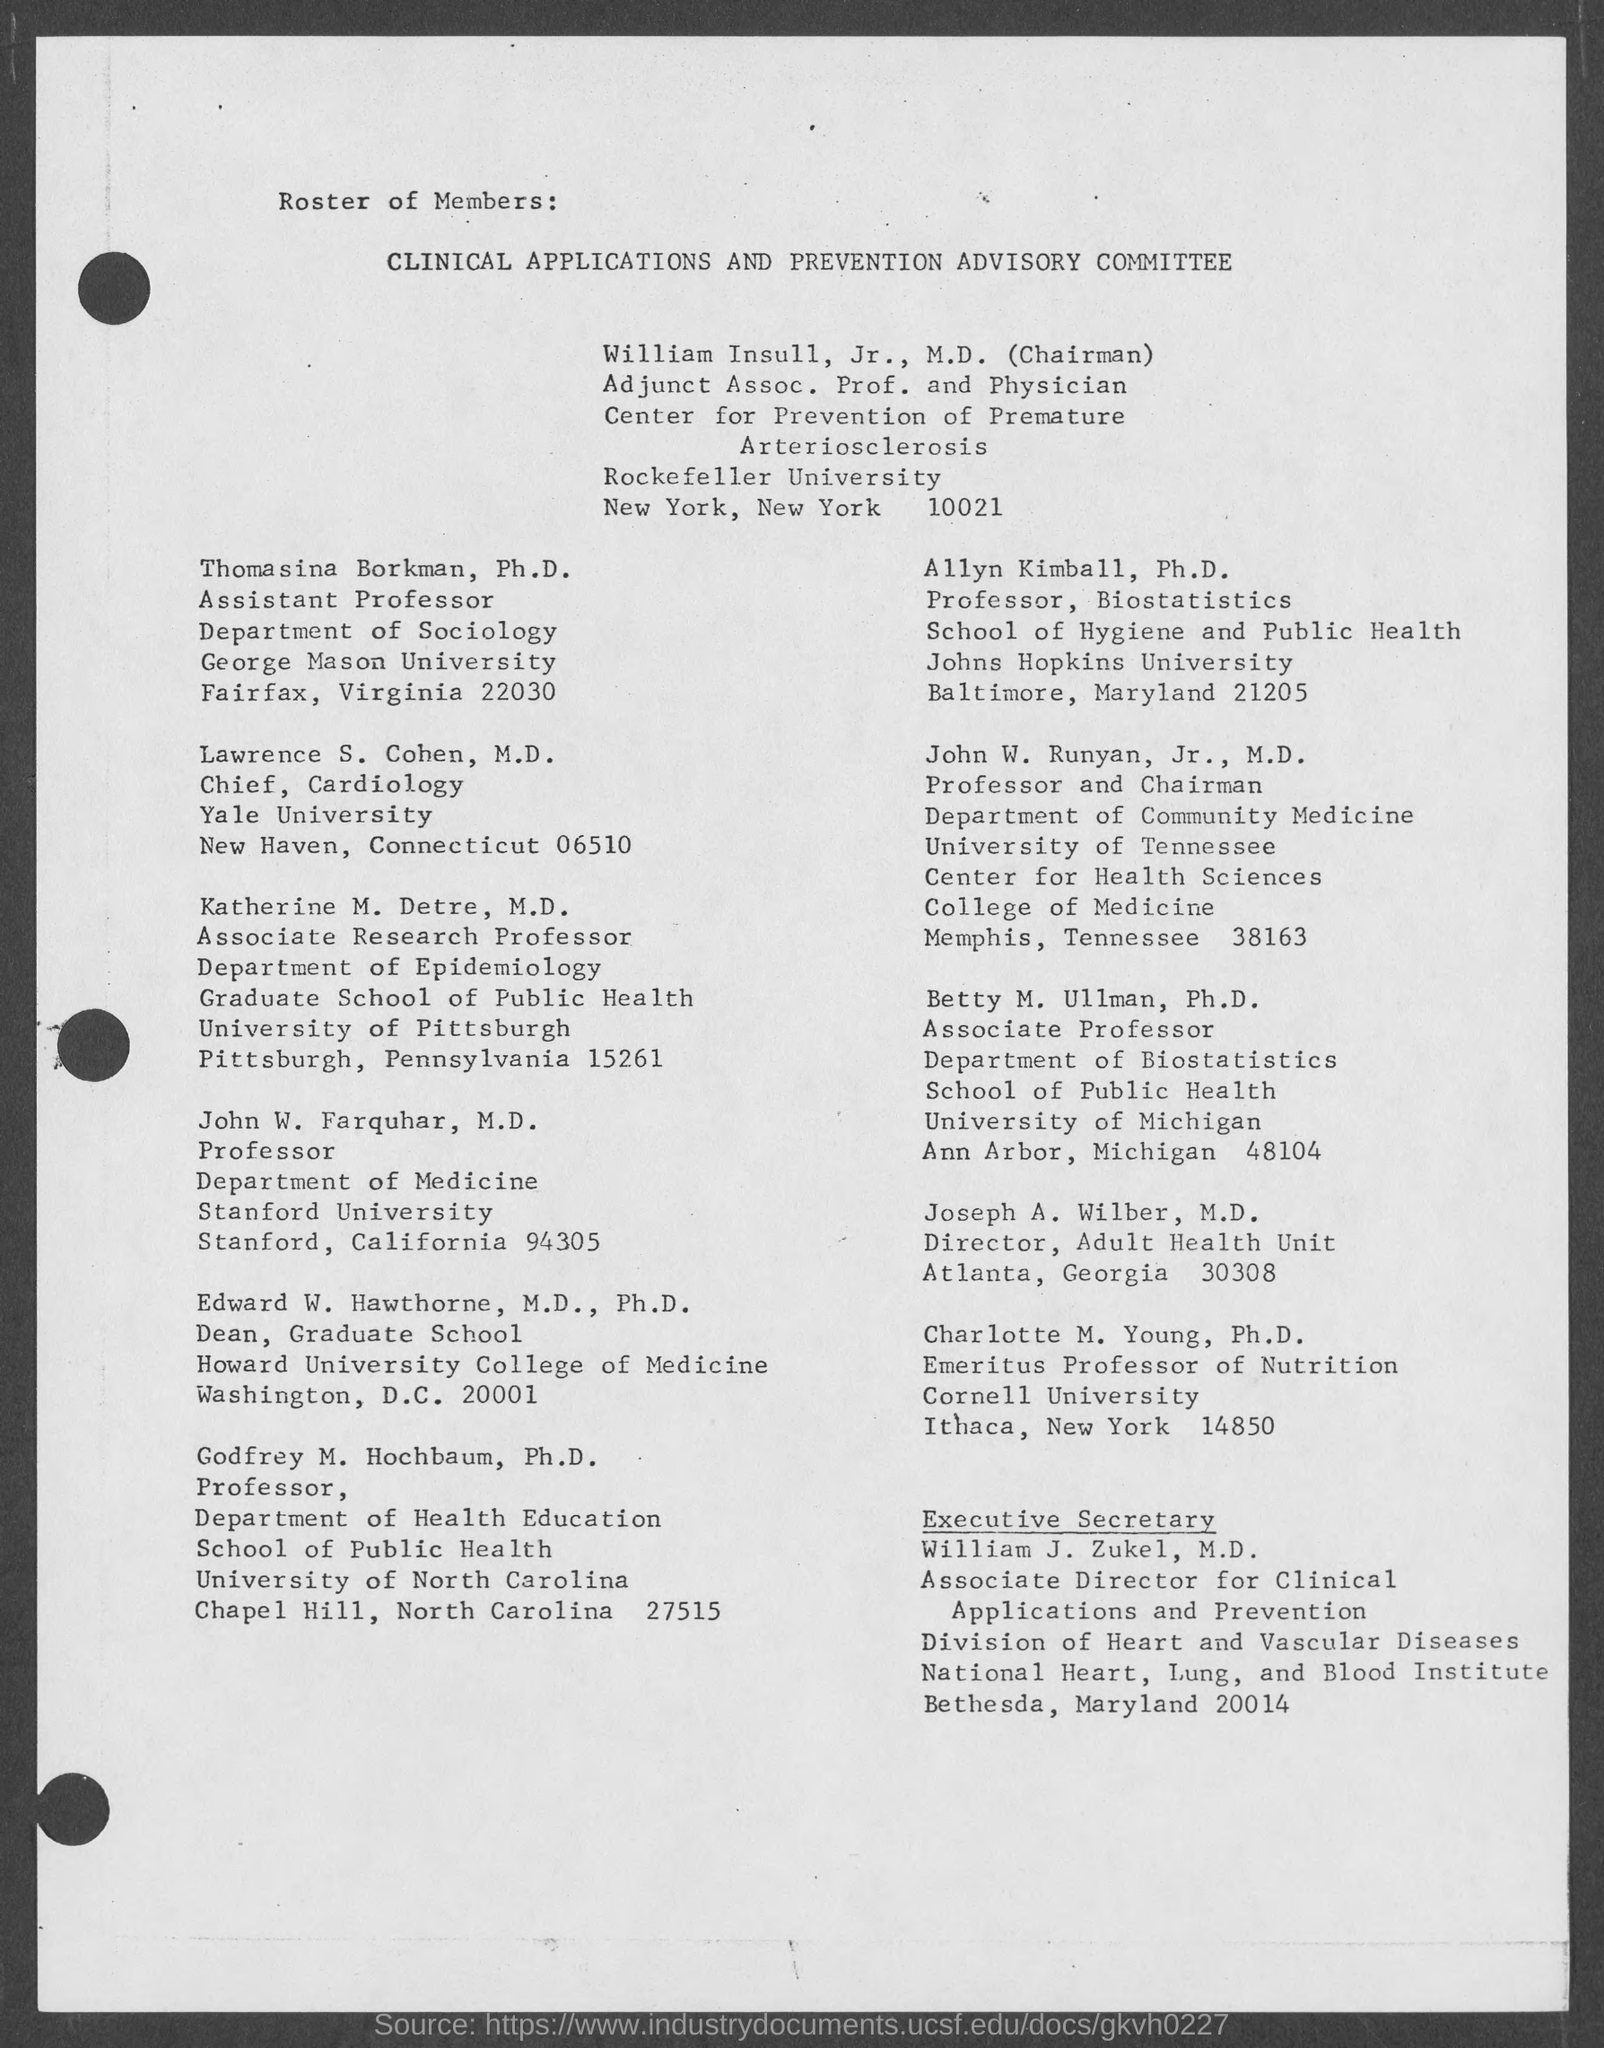Highlight a few significant elements in this photo. The Chairman of the Clinical Applications and Prevention Advisory Committee is William Insull, Jr., M.D. Dr. Lawrence S. Cohen is the Chief of Cardiology at Yale University. William J. Zukel, M.D., is the executive secretary of the Clinical Applications and Prevention Advisory Committee. 